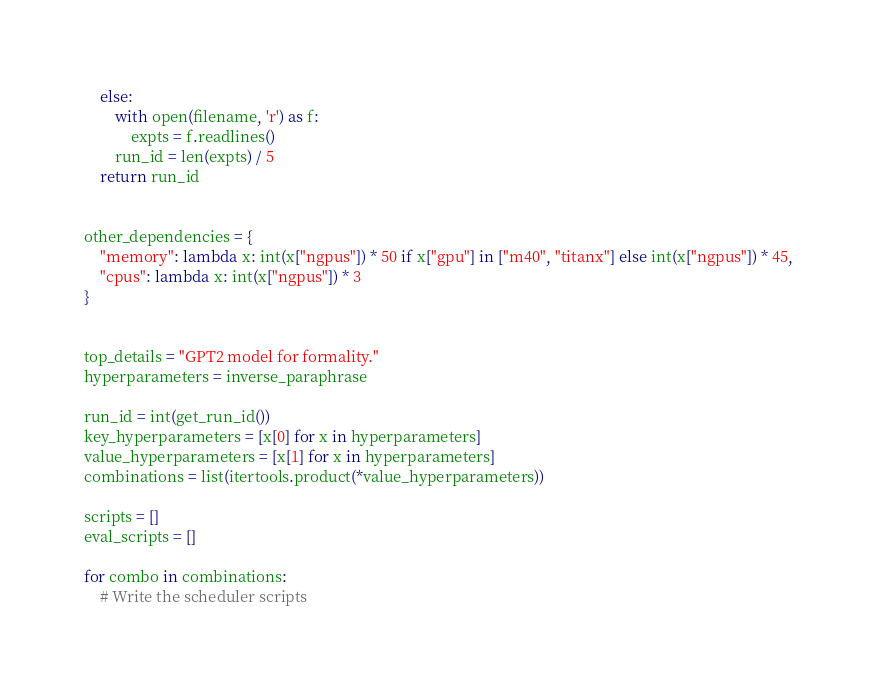Convert code to text. <code><loc_0><loc_0><loc_500><loc_500><_Python_>    else:
        with open(filename, 'r') as f:
            expts = f.readlines()
        run_id = len(expts) / 5
    return run_id


other_dependencies = {
    "memory": lambda x: int(x["ngpus"]) * 50 if x["gpu"] in ["m40", "titanx"] else int(x["ngpus"]) * 45,
    "cpus": lambda x: int(x["ngpus"]) * 3
}


top_details = "GPT2 model for formality."
hyperparameters = inverse_paraphrase

run_id = int(get_run_id())
key_hyperparameters = [x[0] for x in hyperparameters]
value_hyperparameters = [x[1] for x in hyperparameters]
combinations = list(itertools.product(*value_hyperparameters))

scripts = []
eval_scripts = []

for combo in combinations:
    # Write the scheduler scripts</code> 